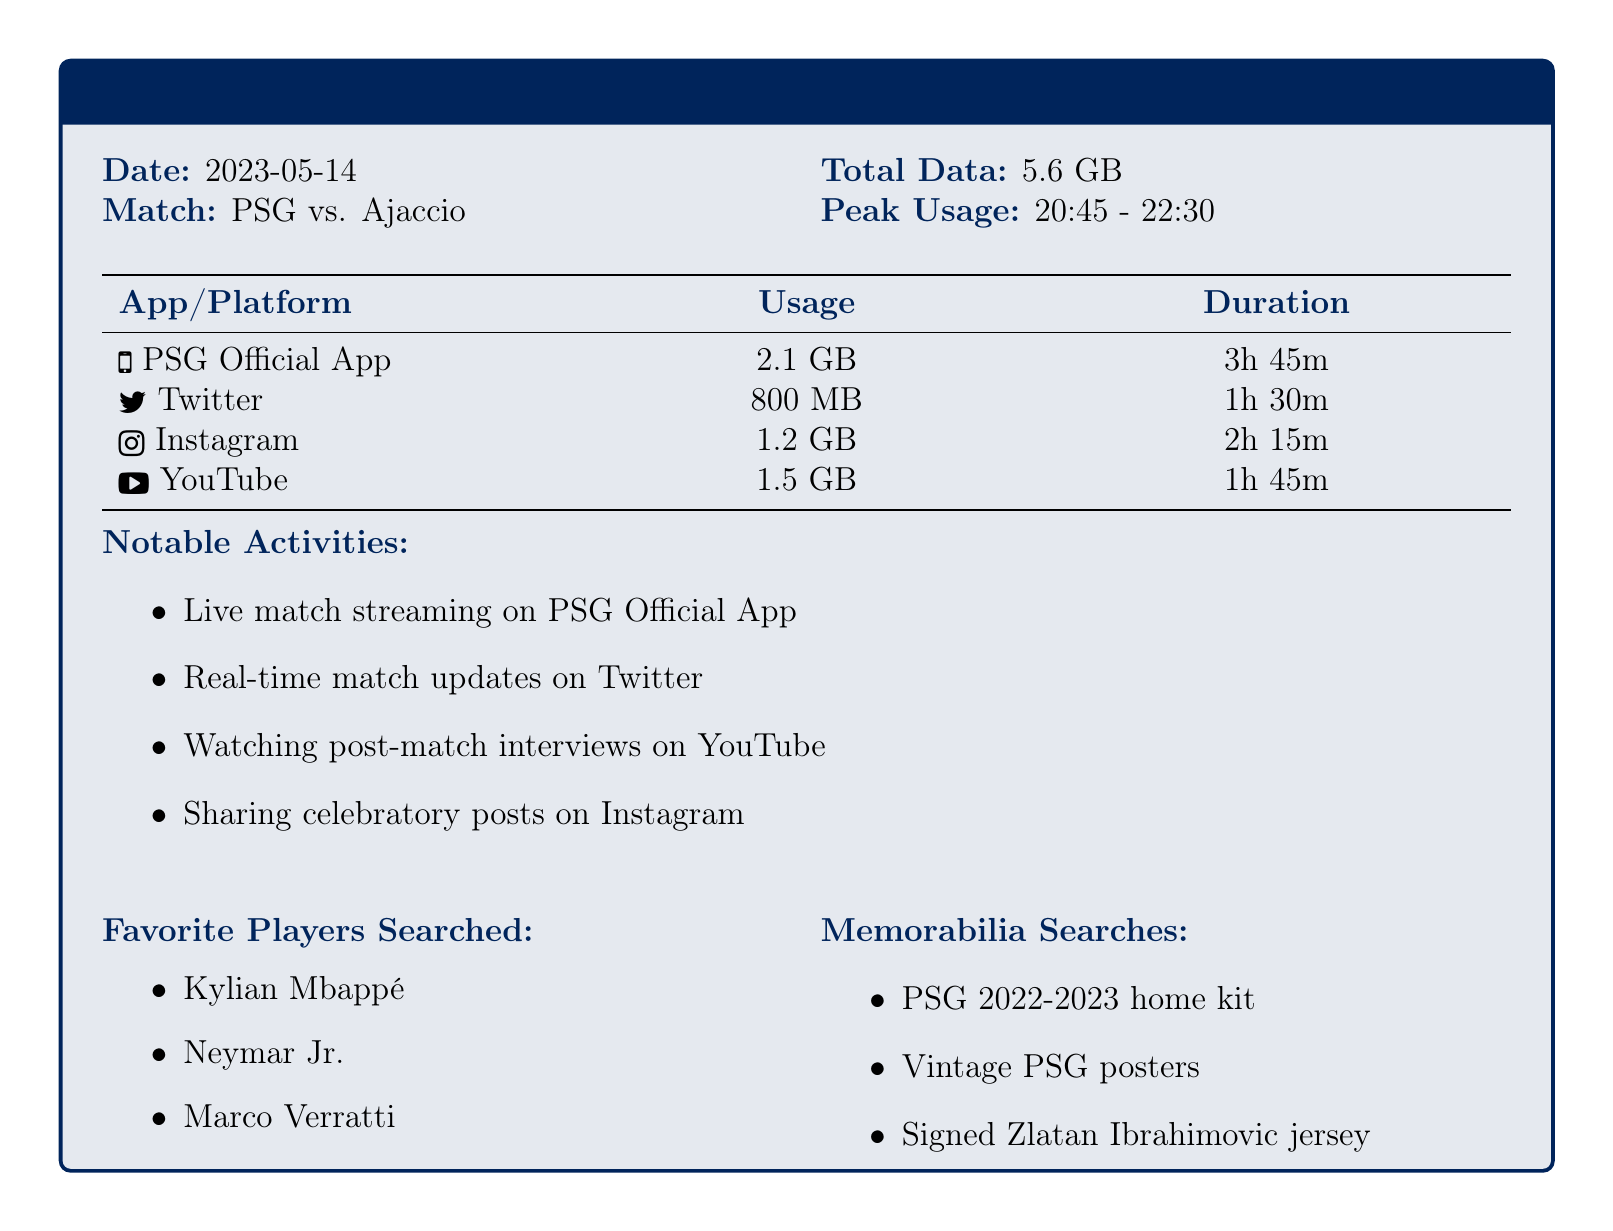what is the date of the match? The date of the match is provided in the document as 2023-05-14.
Answer: 2023-05-14 who did PSG play against? The opponent team is mentioned in the document as Ajaccio.
Answer: Ajaccio what is the total data used during the match? The document specifies that the total data used is 5.6 GB.
Answer: 5.6 GB which app had the highest data usage? The app with the highest data usage according to the table is the PSG Official App at 2.1 GB.
Answer: PSG Official App what time did peak usage occur? Peak usage time is indicated in the document from 20:45 to 22:30.
Answer: 20:45 - 22:30 how many hours were spent on Instagram? According to the table, the usage duration for Instagram is 2 hours and 15 minutes.
Answer: 2h 15m what notable activity was performed on Twitter? The notable activity listed for Twitter is real-time match updates.
Answer: Real-time match updates which players were searched for during the match? The favorite players searched as noted in the document are Kylian Mbappé, Neymar Jr., and Marco Verratti.
Answer: Kylian Mbappé, Neymar Jr., Marco Verratti what type of memorabilia was searched? The document lists PSG 2022-2023 home kit, vintage PSG posters, and signed Zlatan Ibrahimovic jersey as searched memorabilia.
Answer: PSG 2022-2023 home kit, vintage PSG posters, signed Zlatan Ibrahimovic jersey 